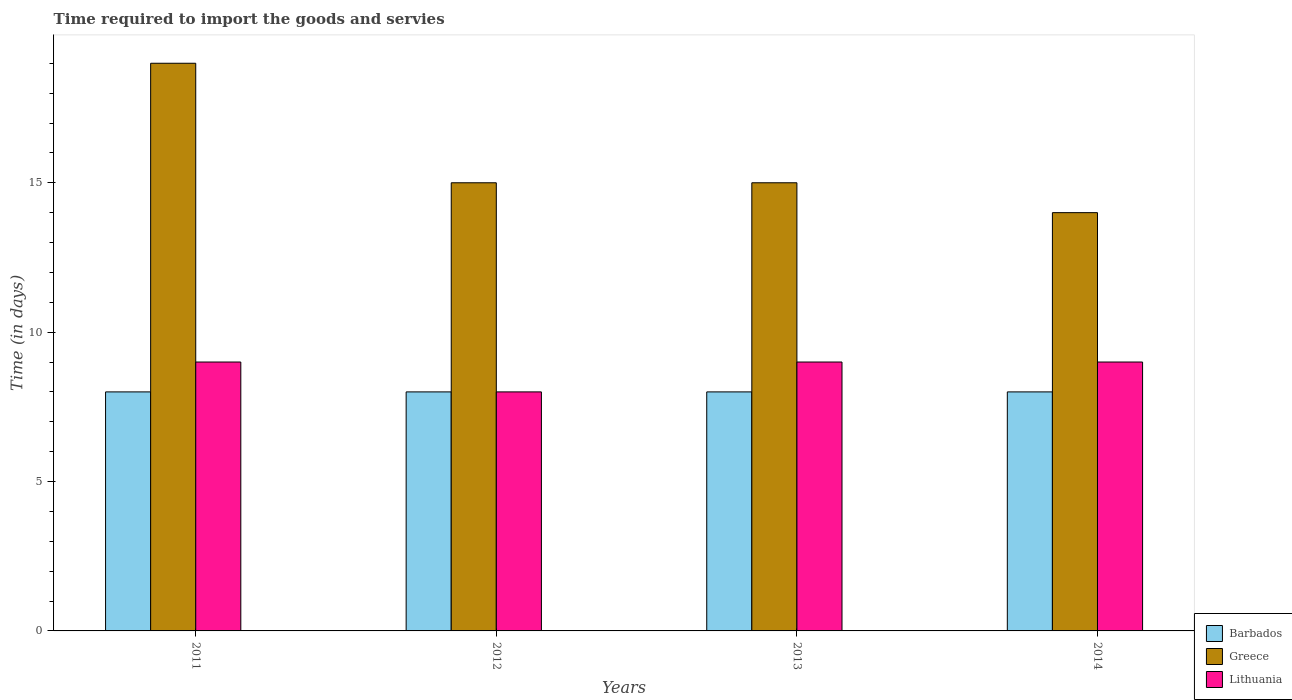How many groups of bars are there?
Ensure brevity in your answer.  4. Are the number of bars per tick equal to the number of legend labels?
Offer a terse response. Yes. Are the number of bars on each tick of the X-axis equal?
Make the answer very short. Yes. How many bars are there on the 4th tick from the right?
Ensure brevity in your answer.  3. What is the label of the 4th group of bars from the left?
Keep it short and to the point. 2014. What is the number of days required to import the goods and services in Greece in 2012?
Keep it short and to the point. 15. Across all years, what is the maximum number of days required to import the goods and services in Greece?
Make the answer very short. 19. Across all years, what is the minimum number of days required to import the goods and services in Lithuania?
Provide a succinct answer. 8. What is the total number of days required to import the goods and services in Lithuania in the graph?
Offer a very short reply. 35. What is the difference between the number of days required to import the goods and services in Barbados in 2013 and that in 2014?
Make the answer very short. 0. In how many years, is the number of days required to import the goods and services in Greece greater than 6 days?
Keep it short and to the point. 4. What is the ratio of the number of days required to import the goods and services in Lithuania in 2011 to that in 2014?
Offer a very short reply. 1. Is the difference between the number of days required to import the goods and services in Lithuania in 2011 and 2014 greater than the difference between the number of days required to import the goods and services in Barbados in 2011 and 2014?
Your response must be concise. No. What is the difference between the highest and the lowest number of days required to import the goods and services in Lithuania?
Provide a succinct answer. 1. What does the 3rd bar from the left in 2013 represents?
Provide a short and direct response. Lithuania. What does the 1st bar from the right in 2014 represents?
Your response must be concise. Lithuania. Is it the case that in every year, the sum of the number of days required to import the goods and services in Greece and number of days required to import the goods and services in Barbados is greater than the number of days required to import the goods and services in Lithuania?
Keep it short and to the point. Yes. How many years are there in the graph?
Ensure brevity in your answer.  4. What is the difference between two consecutive major ticks on the Y-axis?
Make the answer very short. 5. Are the values on the major ticks of Y-axis written in scientific E-notation?
Your answer should be very brief. No. Does the graph contain grids?
Make the answer very short. No. How are the legend labels stacked?
Your answer should be very brief. Vertical. What is the title of the graph?
Keep it short and to the point. Time required to import the goods and servies. What is the label or title of the Y-axis?
Offer a very short reply. Time (in days). What is the Time (in days) in Barbados in 2011?
Your response must be concise. 8. What is the Time (in days) of Greece in 2011?
Provide a short and direct response. 19. What is the Time (in days) of Lithuania in 2011?
Offer a terse response. 9. What is the Time (in days) of Barbados in 2012?
Ensure brevity in your answer.  8. What is the Time (in days) in Lithuania in 2012?
Offer a terse response. 8. What is the Time (in days) of Lithuania in 2013?
Make the answer very short. 9. What is the Time (in days) in Barbados in 2014?
Make the answer very short. 8. Across all years, what is the maximum Time (in days) of Barbados?
Make the answer very short. 8. Across all years, what is the maximum Time (in days) in Lithuania?
Your answer should be very brief. 9. Across all years, what is the minimum Time (in days) in Barbados?
Give a very brief answer. 8. Across all years, what is the minimum Time (in days) of Greece?
Ensure brevity in your answer.  14. What is the difference between the Time (in days) in Greece in 2011 and that in 2012?
Keep it short and to the point. 4. What is the difference between the Time (in days) of Lithuania in 2011 and that in 2012?
Your answer should be compact. 1. What is the difference between the Time (in days) in Lithuania in 2011 and that in 2014?
Make the answer very short. 0. What is the difference between the Time (in days) in Greece in 2012 and that in 2014?
Your answer should be very brief. 1. What is the difference between the Time (in days) in Barbados in 2013 and that in 2014?
Ensure brevity in your answer.  0. What is the difference between the Time (in days) in Greece in 2013 and that in 2014?
Offer a very short reply. 1. What is the difference between the Time (in days) of Barbados in 2011 and the Time (in days) of Greece in 2012?
Your answer should be very brief. -7. What is the difference between the Time (in days) of Barbados in 2011 and the Time (in days) of Lithuania in 2012?
Make the answer very short. 0. What is the difference between the Time (in days) of Greece in 2011 and the Time (in days) of Lithuania in 2012?
Provide a succinct answer. 11. What is the difference between the Time (in days) of Barbados in 2011 and the Time (in days) of Greece in 2013?
Your answer should be compact. -7. What is the difference between the Time (in days) in Greece in 2011 and the Time (in days) in Lithuania in 2013?
Make the answer very short. 10. What is the difference between the Time (in days) of Barbados in 2011 and the Time (in days) of Greece in 2014?
Offer a terse response. -6. What is the difference between the Time (in days) of Barbados in 2011 and the Time (in days) of Lithuania in 2014?
Give a very brief answer. -1. What is the difference between the Time (in days) of Greece in 2011 and the Time (in days) of Lithuania in 2014?
Offer a terse response. 10. What is the difference between the Time (in days) of Greece in 2012 and the Time (in days) of Lithuania in 2013?
Offer a terse response. 6. What is the difference between the Time (in days) of Barbados in 2012 and the Time (in days) of Greece in 2014?
Your answer should be very brief. -6. What is the difference between the Time (in days) in Barbados in 2012 and the Time (in days) in Lithuania in 2014?
Provide a succinct answer. -1. What is the difference between the Time (in days) in Greece in 2012 and the Time (in days) in Lithuania in 2014?
Provide a succinct answer. 6. What is the difference between the Time (in days) of Barbados in 2013 and the Time (in days) of Lithuania in 2014?
Ensure brevity in your answer.  -1. What is the average Time (in days) in Greece per year?
Your response must be concise. 15.75. What is the average Time (in days) in Lithuania per year?
Give a very brief answer. 8.75. In the year 2012, what is the difference between the Time (in days) in Barbados and Time (in days) in Greece?
Provide a succinct answer. -7. In the year 2013, what is the difference between the Time (in days) in Barbados and Time (in days) in Lithuania?
Offer a very short reply. -1. In the year 2013, what is the difference between the Time (in days) of Greece and Time (in days) of Lithuania?
Provide a succinct answer. 6. In the year 2014, what is the difference between the Time (in days) in Barbados and Time (in days) in Greece?
Make the answer very short. -6. In the year 2014, what is the difference between the Time (in days) in Greece and Time (in days) in Lithuania?
Your answer should be compact. 5. What is the ratio of the Time (in days) of Barbados in 2011 to that in 2012?
Make the answer very short. 1. What is the ratio of the Time (in days) of Greece in 2011 to that in 2012?
Make the answer very short. 1.27. What is the ratio of the Time (in days) in Lithuania in 2011 to that in 2012?
Give a very brief answer. 1.12. What is the ratio of the Time (in days) in Greece in 2011 to that in 2013?
Your response must be concise. 1.27. What is the ratio of the Time (in days) of Greece in 2011 to that in 2014?
Make the answer very short. 1.36. What is the ratio of the Time (in days) of Barbados in 2012 to that in 2013?
Provide a short and direct response. 1. What is the ratio of the Time (in days) of Greece in 2012 to that in 2013?
Keep it short and to the point. 1. What is the ratio of the Time (in days) in Lithuania in 2012 to that in 2013?
Your response must be concise. 0.89. What is the ratio of the Time (in days) in Barbados in 2012 to that in 2014?
Offer a very short reply. 1. What is the ratio of the Time (in days) of Greece in 2012 to that in 2014?
Provide a succinct answer. 1.07. What is the ratio of the Time (in days) of Greece in 2013 to that in 2014?
Your answer should be very brief. 1.07. What is the ratio of the Time (in days) of Lithuania in 2013 to that in 2014?
Offer a terse response. 1. What is the difference between the highest and the second highest Time (in days) of Barbados?
Your answer should be very brief. 0. What is the difference between the highest and the second highest Time (in days) in Greece?
Provide a succinct answer. 4. What is the difference between the highest and the lowest Time (in days) in Lithuania?
Provide a short and direct response. 1. 